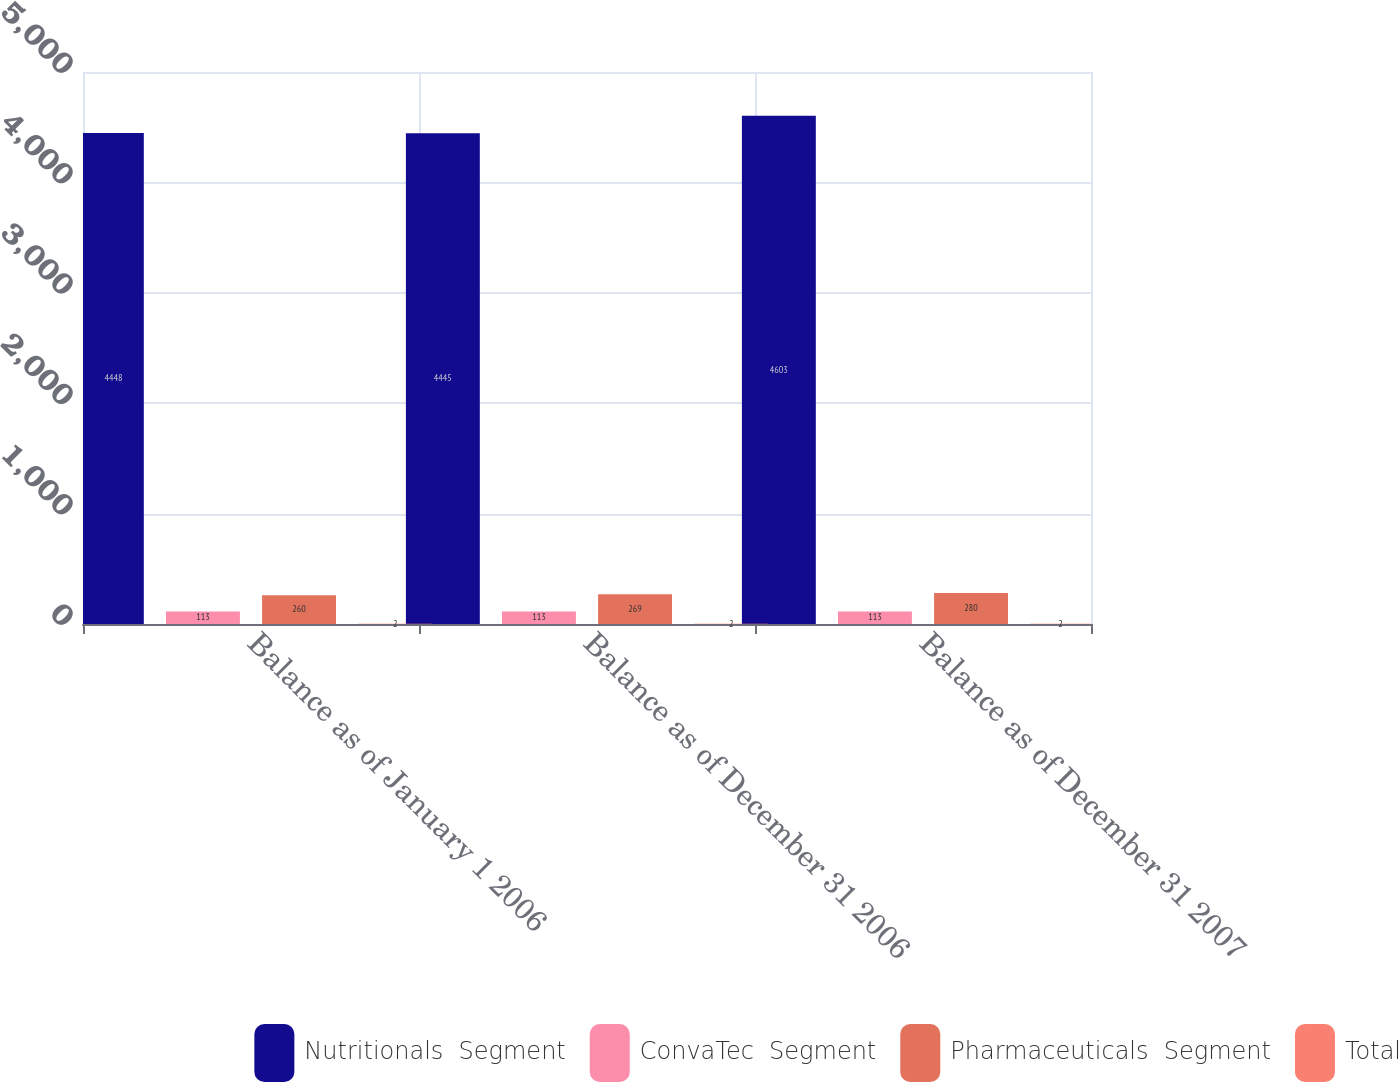<chart> <loc_0><loc_0><loc_500><loc_500><stacked_bar_chart><ecel><fcel>Balance as of January 1 2006<fcel>Balance as of December 31 2006<fcel>Balance as of December 31 2007<nl><fcel>Nutritionals  Segment<fcel>4448<fcel>4445<fcel>4603<nl><fcel>ConvaTec  Segment<fcel>113<fcel>113<fcel>113<nl><fcel>Pharmaceuticals  Segment<fcel>260<fcel>269<fcel>280<nl><fcel>Total<fcel>2<fcel>2<fcel>2<nl></chart> 